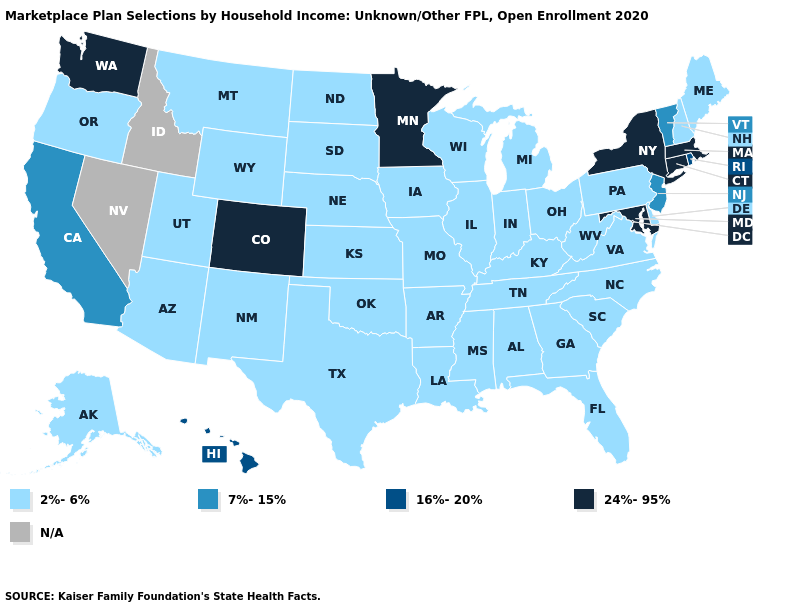What is the lowest value in the USA?
Keep it brief. 2%-6%. Name the states that have a value in the range 7%-15%?
Short answer required. California, New Jersey, Vermont. Which states hav the highest value in the South?
Short answer required. Maryland. What is the lowest value in the USA?
Be succinct. 2%-6%. Does the map have missing data?
Be succinct. Yes. Among the states that border Vermont , which have the lowest value?
Short answer required. New Hampshire. Does Maryland have the highest value in the USA?
Write a very short answer. Yes. Among the states that border Arkansas , which have the lowest value?
Concise answer only. Louisiana, Mississippi, Missouri, Oklahoma, Tennessee, Texas. Which states have the highest value in the USA?
Write a very short answer. Colorado, Connecticut, Maryland, Massachusetts, Minnesota, New York, Washington. Name the states that have a value in the range 7%-15%?
Short answer required. California, New Jersey, Vermont. What is the highest value in the West ?
Be succinct. 24%-95%. What is the value of Kentucky?
Short answer required. 2%-6%. What is the highest value in the Northeast ?
Be succinct. 24%-95%. Name the states that have a value in the range 2%-6%?
Be succinct. Alabama, Alaska, Arizona, Arkansas, Delaware, Florida, Georgia, Illinois, Indiana, Iowa, Kansas, Kentucky, Louisiana, Maine, Michigan, Mississippi, Missouri, Montana, Nebraska, New Hampshire, New Mexico, North Carolina, North Dakota, Ohio, Oklahoma, Oregon, Pennsylvania, South Carolina, South Dakota, Tennessee, Texas, Utah, Virginia, West Virginia, Wisconsin, Wyoming. 